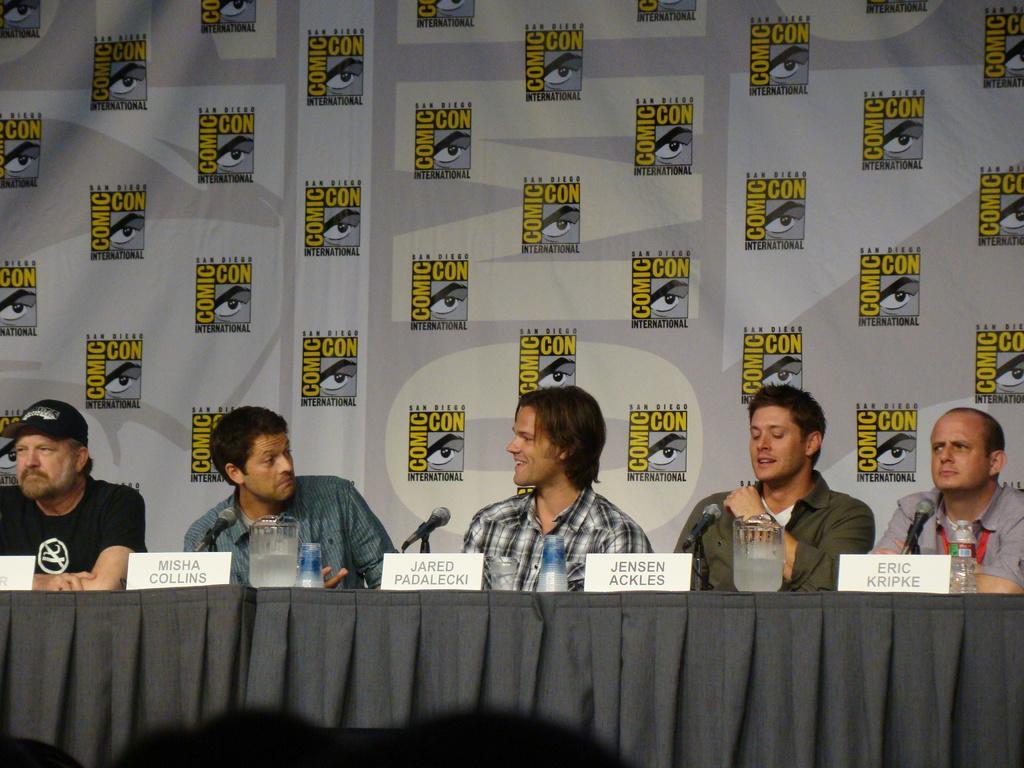Please provide a concise description of this image. In this image there are some people sitting and some of them are smiling, and in front of them there is a table and the table is covered with cloth. On the table there are some bottles, glasses, and miles and in the background there is a board. On the board there is some text. 